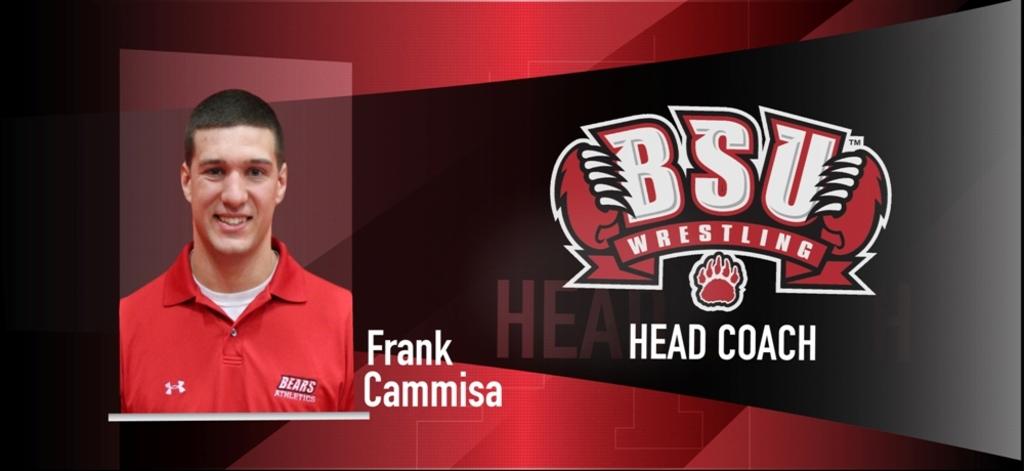Who is that?
Provide a succinct answer. Frank cammisa. 